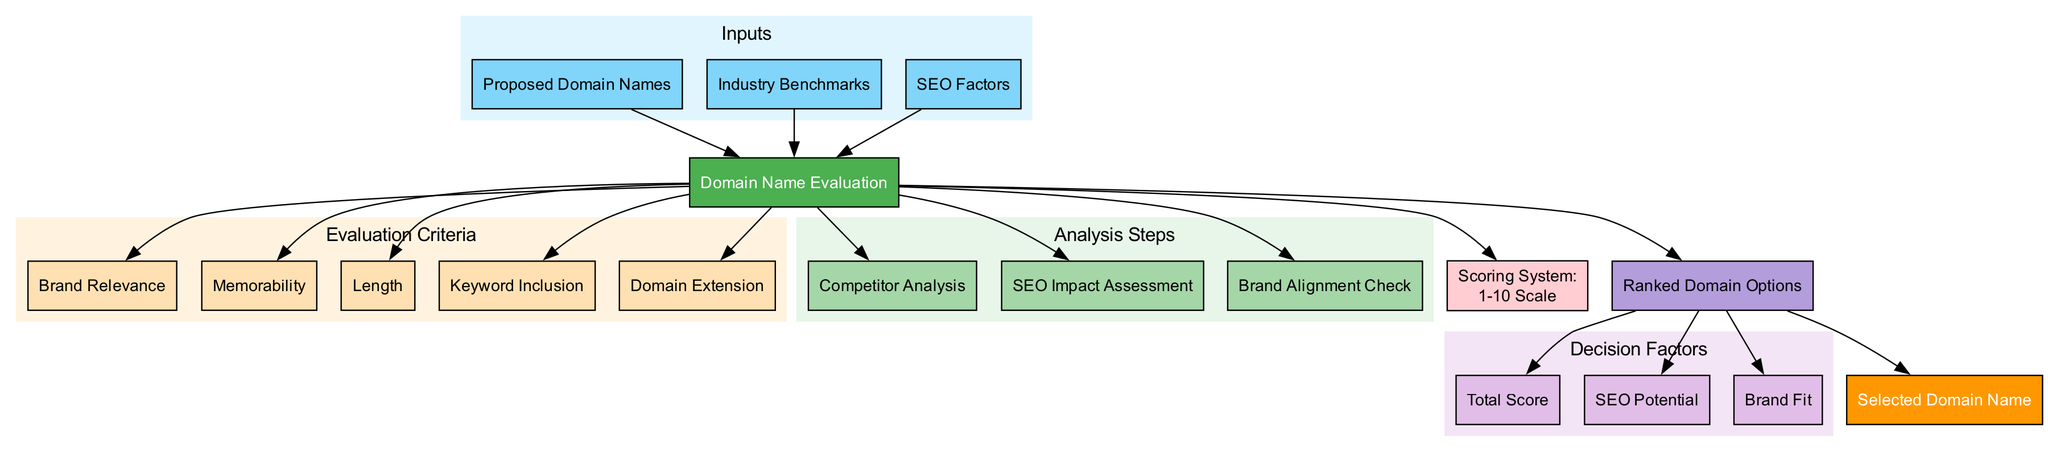What are the inputs for the domain name evaluation? The diagram lists three inputs under the "Inputs" cluster: Proposed Domain Names, Industry Benchmarks, and SEO Factors.
Answer: Proposed Domain Names, Industry Benchmarks, SEO Factors How many evaluation criteria are there? The diagram shows five nodes in the "Evaluation Criteria" cluster, indicating there are five criteria listed: Brand Relevance, Memorability, Length, Keyword Inclusion, and Domain Extension.
Answer: 5 What is the scoring system used in the evaluation? The scoring system is explicitly mentioned in the diagram as a "1-10 Scale," which refers to the range for evaluating domain options.
Answer: 1-10 Scale What is the output of the domain name evaluation process? The output node in the diagram clearly states "Ranked Domain Options," providing a direct answer regarding the result of the evaluation process.
Answer: Ranked Domain Options Which decision factor indicates potential for search engine optimization? Among the decision factors listed, "SEO Potential" specifically highlights the factor related to the potential impact on search engine optimization.
Answer: SEO Potential What is the relationship between the main process and the evaluation criteria? The diagram illustrates that the main process of "Domain Name Evaluation" is directly connected to each of the evaluation criteria nodes, indicating that they are all evaluated as part of the overall process.
Answer: Direct Connection How many analysis steps are included in the process? The diagram includes three distinct nodes under the "Analysis Steps" cluster, denoting that there are three specific analytical steps performed during the domain name evaluation.
Answer: 3 What is the final outcome of the evaluation process? The final outcome is indicated in the diagram as "Selected Domain Name," demonstrating what results from the evaluation based on the processed information.
Answer: Selected Domain Name Which step in the analysis addresses brand alignment? The diagram includes "Brand Alignment Check" as one of the analysis steps, directly indicating which step focuses on evaluating alignment with the brand.
Answer: Brand Alignment Check 